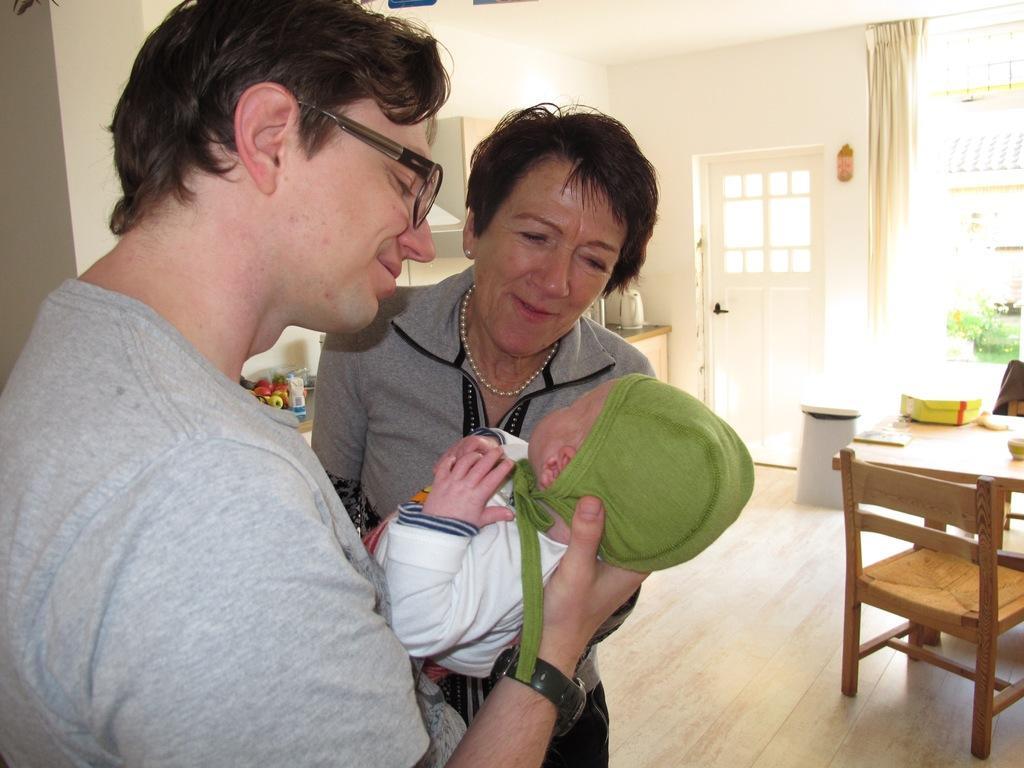Could you give a brief overview of what you see in this image? In this image, few peoples are there. The man is holding a baby. The right side, we can see wooden chair and wooden table. There are few items are placed on it. Here we can see curtain, door, table and few things. And here we can see few veggies and floor. 